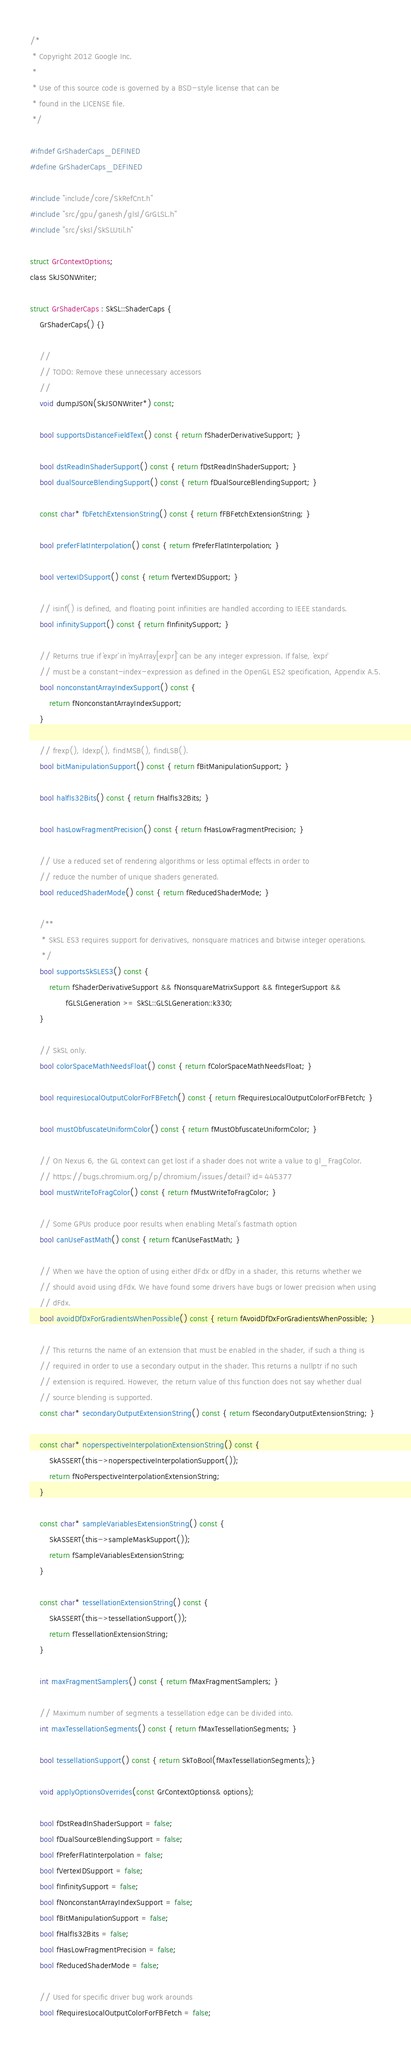<code> <loc_0><loc_0><loc_500><loc_500><_C_>/*
 * Copyright 2012 Google Inc.
 *
 * Use of this source code is governed by a BSD-style license that can be
 * found in the LICENSE file.
 */

#ifndef GrShaderCaps_DEFINED
#define GrShaderCaps_DEFINED

#include "include/core/SkRefCnt.h"
#include "src/gpu/ganesh/glsl/GrGLSL.h"
#include "src/sksl/SkSLUtil.h"

struct GrContextOptions;
class SkJSONWriter;

struct GrShaderCaps : SkSL::ShaderCaps {
    GrShaderCaps() {}

    //
    // TODO: Remove these unnecessary accessors
    //
    void dumpJSON(SkJSONWriter*) const;

    bool supportsDistanceFieldText() const { return fShaderDerivativeSupport; }

    bool dstReadInShaderSupport() const { return fDstReadInShaderSupport; }
    bool dualSourceBlendingSupport() const { return fDualSourceBlendingSupport; }

    const char* fbFetchExtensionString() const { return fFBFetchExtensionString; }

    bool preferFlatInterpolation() const { return fPreferFlatInterpolation; }

    bool vertexIDSupport() const { return fVertexIDSupport; }

    // isinf() is defined, and floating point infinities are handled according to IEEE standards.
    bool infinitySupport() const { return fInfinitySupport; }

    // Returns true if `expr` in `myArray[expr]` can be any integer expression. If false, `expr`
    // must be a constant-index-expression as defined in the OpenGL ES2 specification, Appendix A.5.
    bool nonconstantArrayIndexSupport() const {
        return fNonconstantArrayIndexSupport;
    }

    // frexp(), ldexp(), findMSB(), findLSB().
    bool bitManipulationSupport() const { return fBitManipulationSupport; }

    bool halfIs32Bits() const { return fHalfIs32Bits; }

    bool hasLowFragmentPrecision() const { return fHasLowFragmentPrecision; }

    // Use a reduced set of rendering algorithms or less optimal effects in order to
    // reduce the number of unique shaders generated.
    bool reducedShaderMode() const { return fReducedShaderMode; }

    /**
     * SkSL ES3 requires support for derivatives, nonsquare matrices and bitwise integer operations.
     */
    bool supportsSkSLES3() const {
        return fShaderDerivativeSupport && fNonsquareMatrixSupport && fIntegerSupport &&
               fGLSLGeneration >= SkSL::GLSLGeneration::k330;
    }

    // SkSL only.
    bool colorSpaceMathNeedsFloat() const { return fColorSpaceMathNeedsFloat; }

    bool requiresLocalOutputColorForFBFetch() const { return fRequiresLocalOutputColorForFBFetch; }

    bool mustObfuscateUniformColor() const { return fMustObfuscateUniformColor; }

    // On Nexus 6, the GL context can get lost if a shader does not write a value to gl_FragColor.
    // https://bugs.chromium.org/p/chromium/issues/detail?id=445377
    bool mustWriteToFragColor() const { return fMustWriteToFragColor; }

    // Some GPUs produce poor results when enabling Metal's fastmath option
    bool canUseFastMath() const { return fCanUseFastMath; }

    // When we have the option of using either dFdx or dfDy in a shader, this returns whether we
    // should avoid using dFdx. We have found some drivers have bugs or lower precision when using
    // dFdx.
    bool avoidDfDxForGradientsWhenPossible() const { return fAvoidDfDxForGradientsWhenPossible; }

    // This returns the name of an extension that must be enabled in the shader, if such a thing is
    // required in order to use a secondary output in the shader. This returns a nullptr if no such
    // extension is required. However, the return value of this function does not say whether dual
    // source blending is supported.
    const char* secondaryOutputExtensionString() const { return fSecondaryOutputExtensionString; }

    const char* noperspectiveInterpolationExtensionString() const {
        SkASSERT(this->noperspectiveInterpolationSupport());
        return fNoPerspectiveInterpolationExtensionString;
    }

    const char* sampleVariablesExtensionString() const {
        SkASSERT(this->sampleMaskSupport());
        return fSampleVariablesExtensionString;
    }

    const char* tessellationExtensionString() const {
        SkASSERT(this->tessellationSupport());
        return fTessellationExtensionString;
    }

    int maxFragmentSamplers() const { return fMaxFragmentSamplers; }

    // Maximum number of segments a tessellation edge can be divided into.
    int maxTessellationSegments() const { return fMaxTessellationSegments; }

    bool tessellationSupport() const { return SkToBool(fMaxTessellationSegments);}

    void applyOptionsOverrides(const GrContextOptions& options);

    bool fDstReadInShaderSupport = false;
    bool fDualSourceBlendingSupport = false;
    bool fPreferFlatInterpolation = false;
    bool fVertexIDSupport = false;
    bool fInfinitySupport = false;
    bool fNonconstantArrayIndexSupport = false;
    bool fBitManipulationSupport = false;
    bool fHalfIs32Bits = false;
    bool fHasLowFragmentPrecision = false;
    bool fReducedShaderMode = false;

    // Used for specific driver bug work arounds
    bool fRequiresLocalOutputColorForFBFetch = false;</code> 